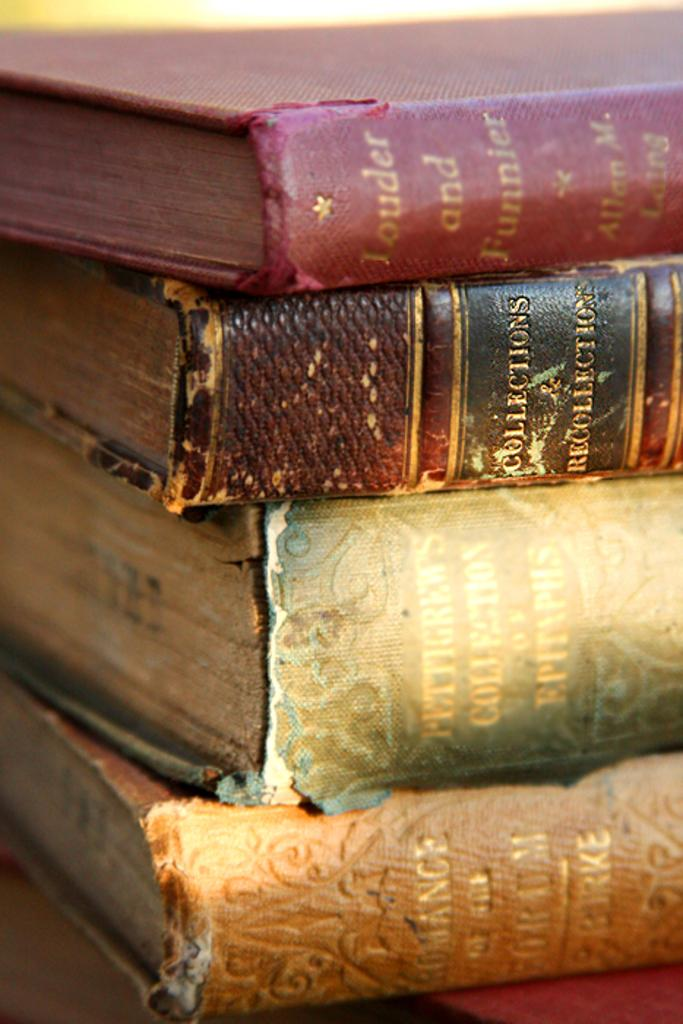<image>
Offer a succinct explanation of the picture presented. A group of four books that are piled up, with the top one being titled "Louder and funnier". 